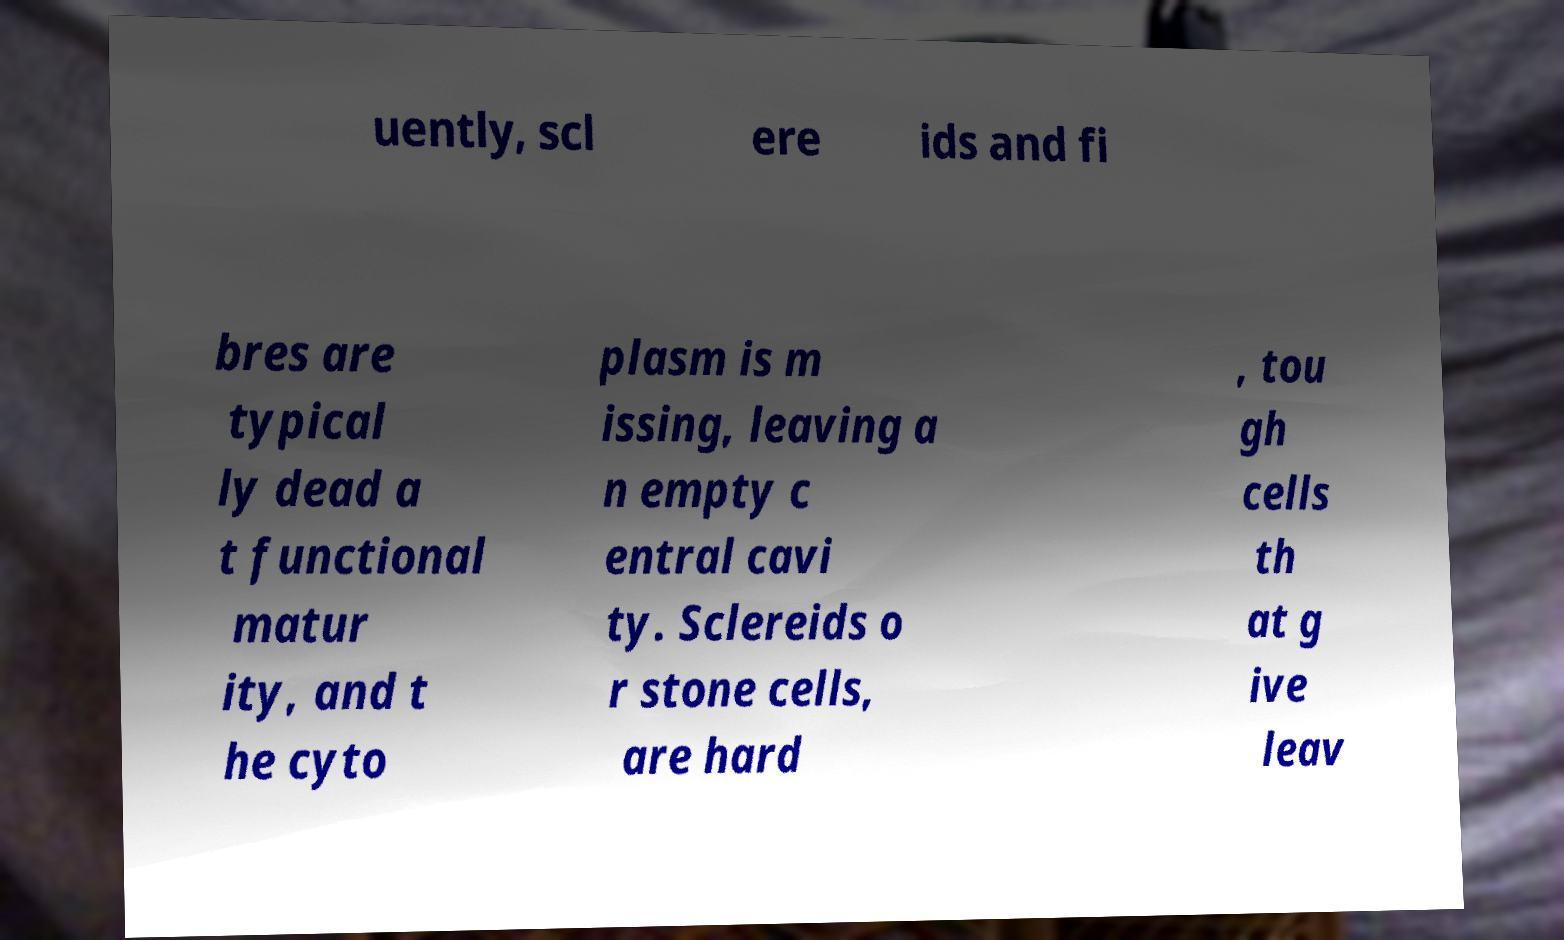There's text embedded in this image that I need extracted. Can you transcribe it verbatim? uently, scl ere ids and fi bres are typical ly dead a t functional matur ity, and t he cyto plasm is m issing, leaving a n empty c entral cavi ty. Sclereids o r stone cells, are hard , tou gh cells th at g ive leav 